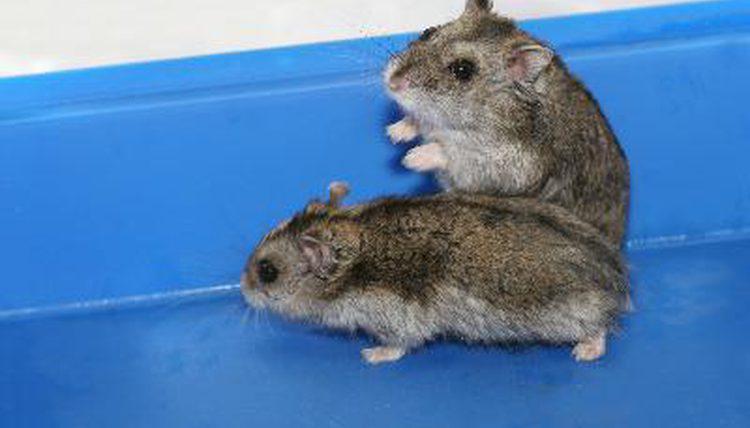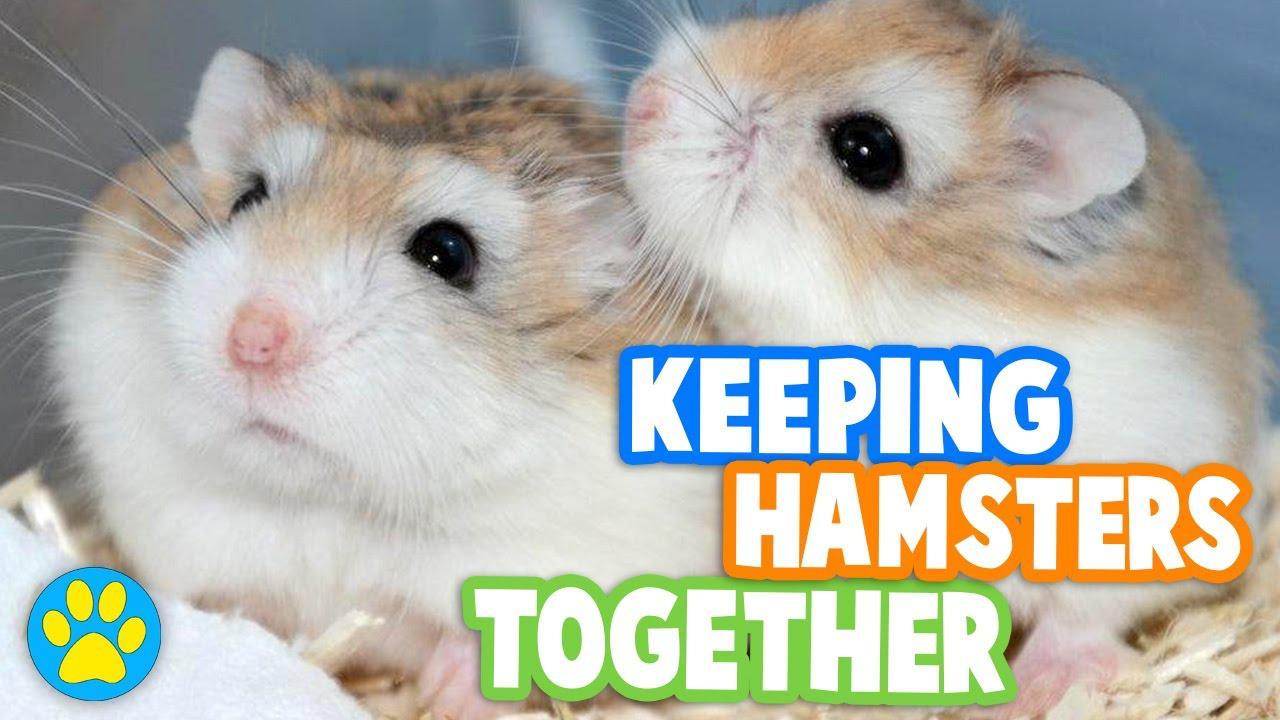The first image is the image on the left, the second image is the image on the right. Assess this claim about the two images: "A human finger is in an image with no more than two hamsters.". Correct or not? Answer yes or no. No. The first image is the image on the left, the second image is the image on the right. Given the left and right images, does the statement "In both images, two hamsters are touching each other." hold true? Answer yes or no. Yes. 